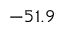<formula> <loc_0><loc_0><loc_500><loc_500>- 5 1 . 9</formula> 